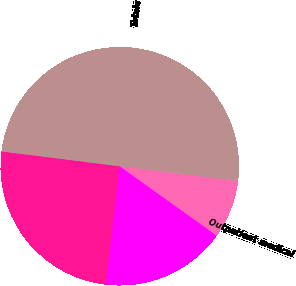<chart> <loc_0><loc_0><loc_500><loc_500><pie_chart><fcel>Triple-net<fcel>Seniors housing operating<fcel>Outpatient medical<fcel>Totals<nl><fcel>25.15%<fcel>16.95%<fcel>7.9%<fcel>50.0%<nl></chart> 